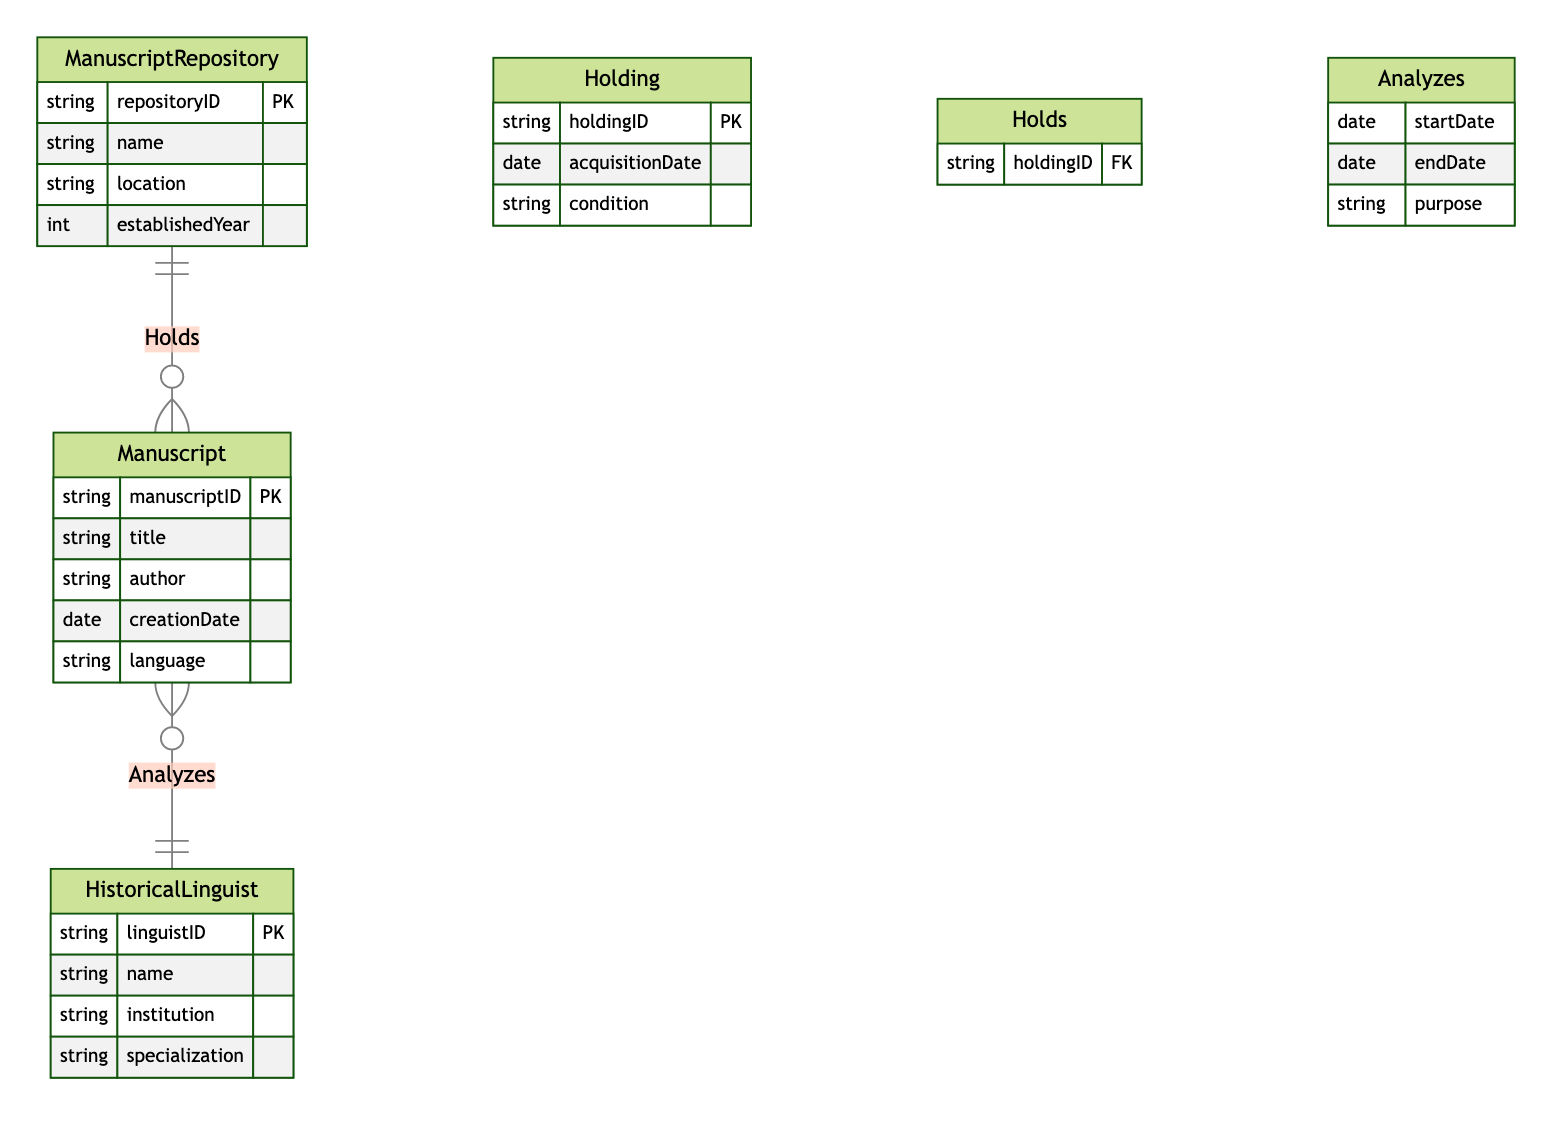What is the primary key attribute of the ManuscriptRepository entity? The primary key attribute of the ManuscriptRepository entity is the repositoryID. This can be identified from the attributes listed under the ManuscriptRepository section in the diagram.
Answer: repositoryID How many entities are present in the diagram? The diagram contains four entities: ManuscriptRepository, Manuscript, Holding, and HistoricalLinguist. By counting these entities, we find the total number.
Answer: four What relationship connects ManuscriptRepository and Manuscript? The relationship that connects ManuscriptRepository and Manuscript is called "Holds." This relationship is shown with a line labeled "Holds" between these two entities in the diagram.
Answer: Holds What is the purpose of the Analyzes relationship? The purpose of the Analyzes relationship between HistoricalLinguist and Manuscript is to indicate the analysis activities performed by linguists on manuscripts. This is detailed in the attributes listed under the Analyzes section.
Answer: analysis activities Which attribute in the HistoricalLinguist entity represents the affiliation of the linguist? The attribute representing the affiliation of the linguist in the HistoricalLinguist entity is "institution." This can be derived from the attributes detailed in the HistoricalLinguist section.
Answer: institution What attributes describe a Holding? The attributes that describe a Holding are holdingID, acquisitionDate, and condition. This information is listed under the Holding entity in the diagram.
Answer: holdingID, acquisitionDate, condition How many relationships are depicted in the diagram? There are two relationships depicted in the diagram: Holds and Analyzes. By reviewing the relationships listed, we can determine the total.
Answer: two What is the foreign key in the Holds relationship? The foreign key in the Holds relationship is holdingID. This is indicated in the Holds relationship attributes section, revealing its link to the Holding entity.
Answer: holdingID Which entity has the language attribute? The Manuscript entity has the language attribute, which is specified in its list of attributes. This can be confirmed by reviewing the attributes under the Manuscript entity.
Answer: Manuscript 